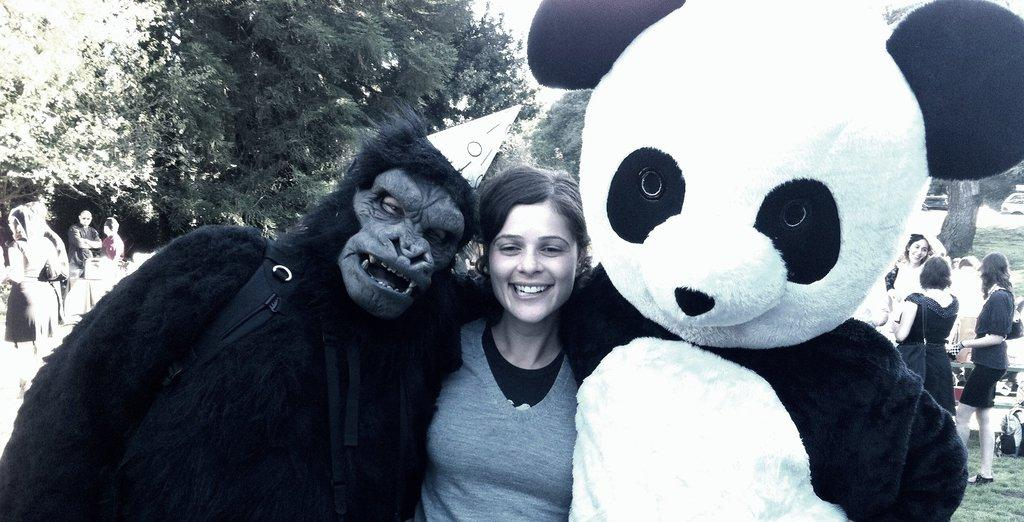How many people are standing in the image? There are three persons standing in the image. What are the two persons wearing? Two of the persons are in fancy dresses. Can you describe the background of the image? There is a group of people standing in the background of the image, and trees are visible as well. What is the governor pointing at in the image? There is no governor present in the image, and therefore no one is pointing at anything. 